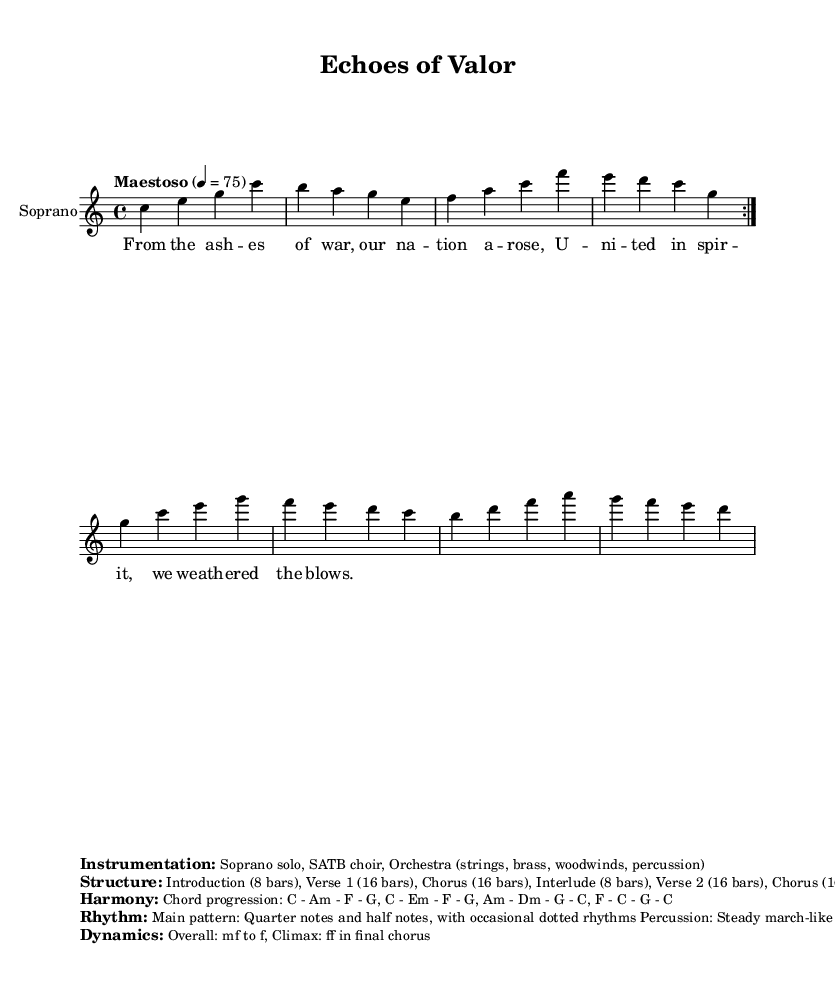What is the key signature of this music? The key signature is presented in the global settings, which indicates that it is set in C major, characterized by the absence of sharps or flats.
Answer: C major What is the time signature of the piece? The time signature is specified in the global section; it is written as 4/4, meaning there are four beats in each measure and the quarter note gets one beat.
Answer: 4/4 What is the tempo marking for this composition? The tempo marking of the piece is indicated in the global settings, showing that it is set to "Maestoso" with a metronome marking of 75 beats per minute, which dictates the pace of the music.
Answer: Maestoso, 4 = 75 How many bars are in the introduction? Referring to the structure provided, the introduction is outlined as having 8 bars, which is specified clearly in the markup section dedicated to structure.
Answer: 8 bars What are the main chords used in the harmony? The chord progression is explicitly detailed in the harmony section, indicating that the main chords used throughout the piece include C, Am, F, and G, among others listed.
Answer: C - Am - F - G What is the dynamic range indicated for the climax? The dynamics are discussed in the dynamics section stating that the overall dynamics range from mezzo-forte to forte, with the climax reaching fortissimo in the final chorus, thus indicating the peak intensity.
Answer: ff What type of instrumentation is featured in this piece? The instrumentation is clearly listed in the markup section, specifying that the piece includes a Soprano solo, SATB choir, and Orchestra, which is typical for opera-style compositions.
Answer: Soprano solo, SATB choir, Orchestra 